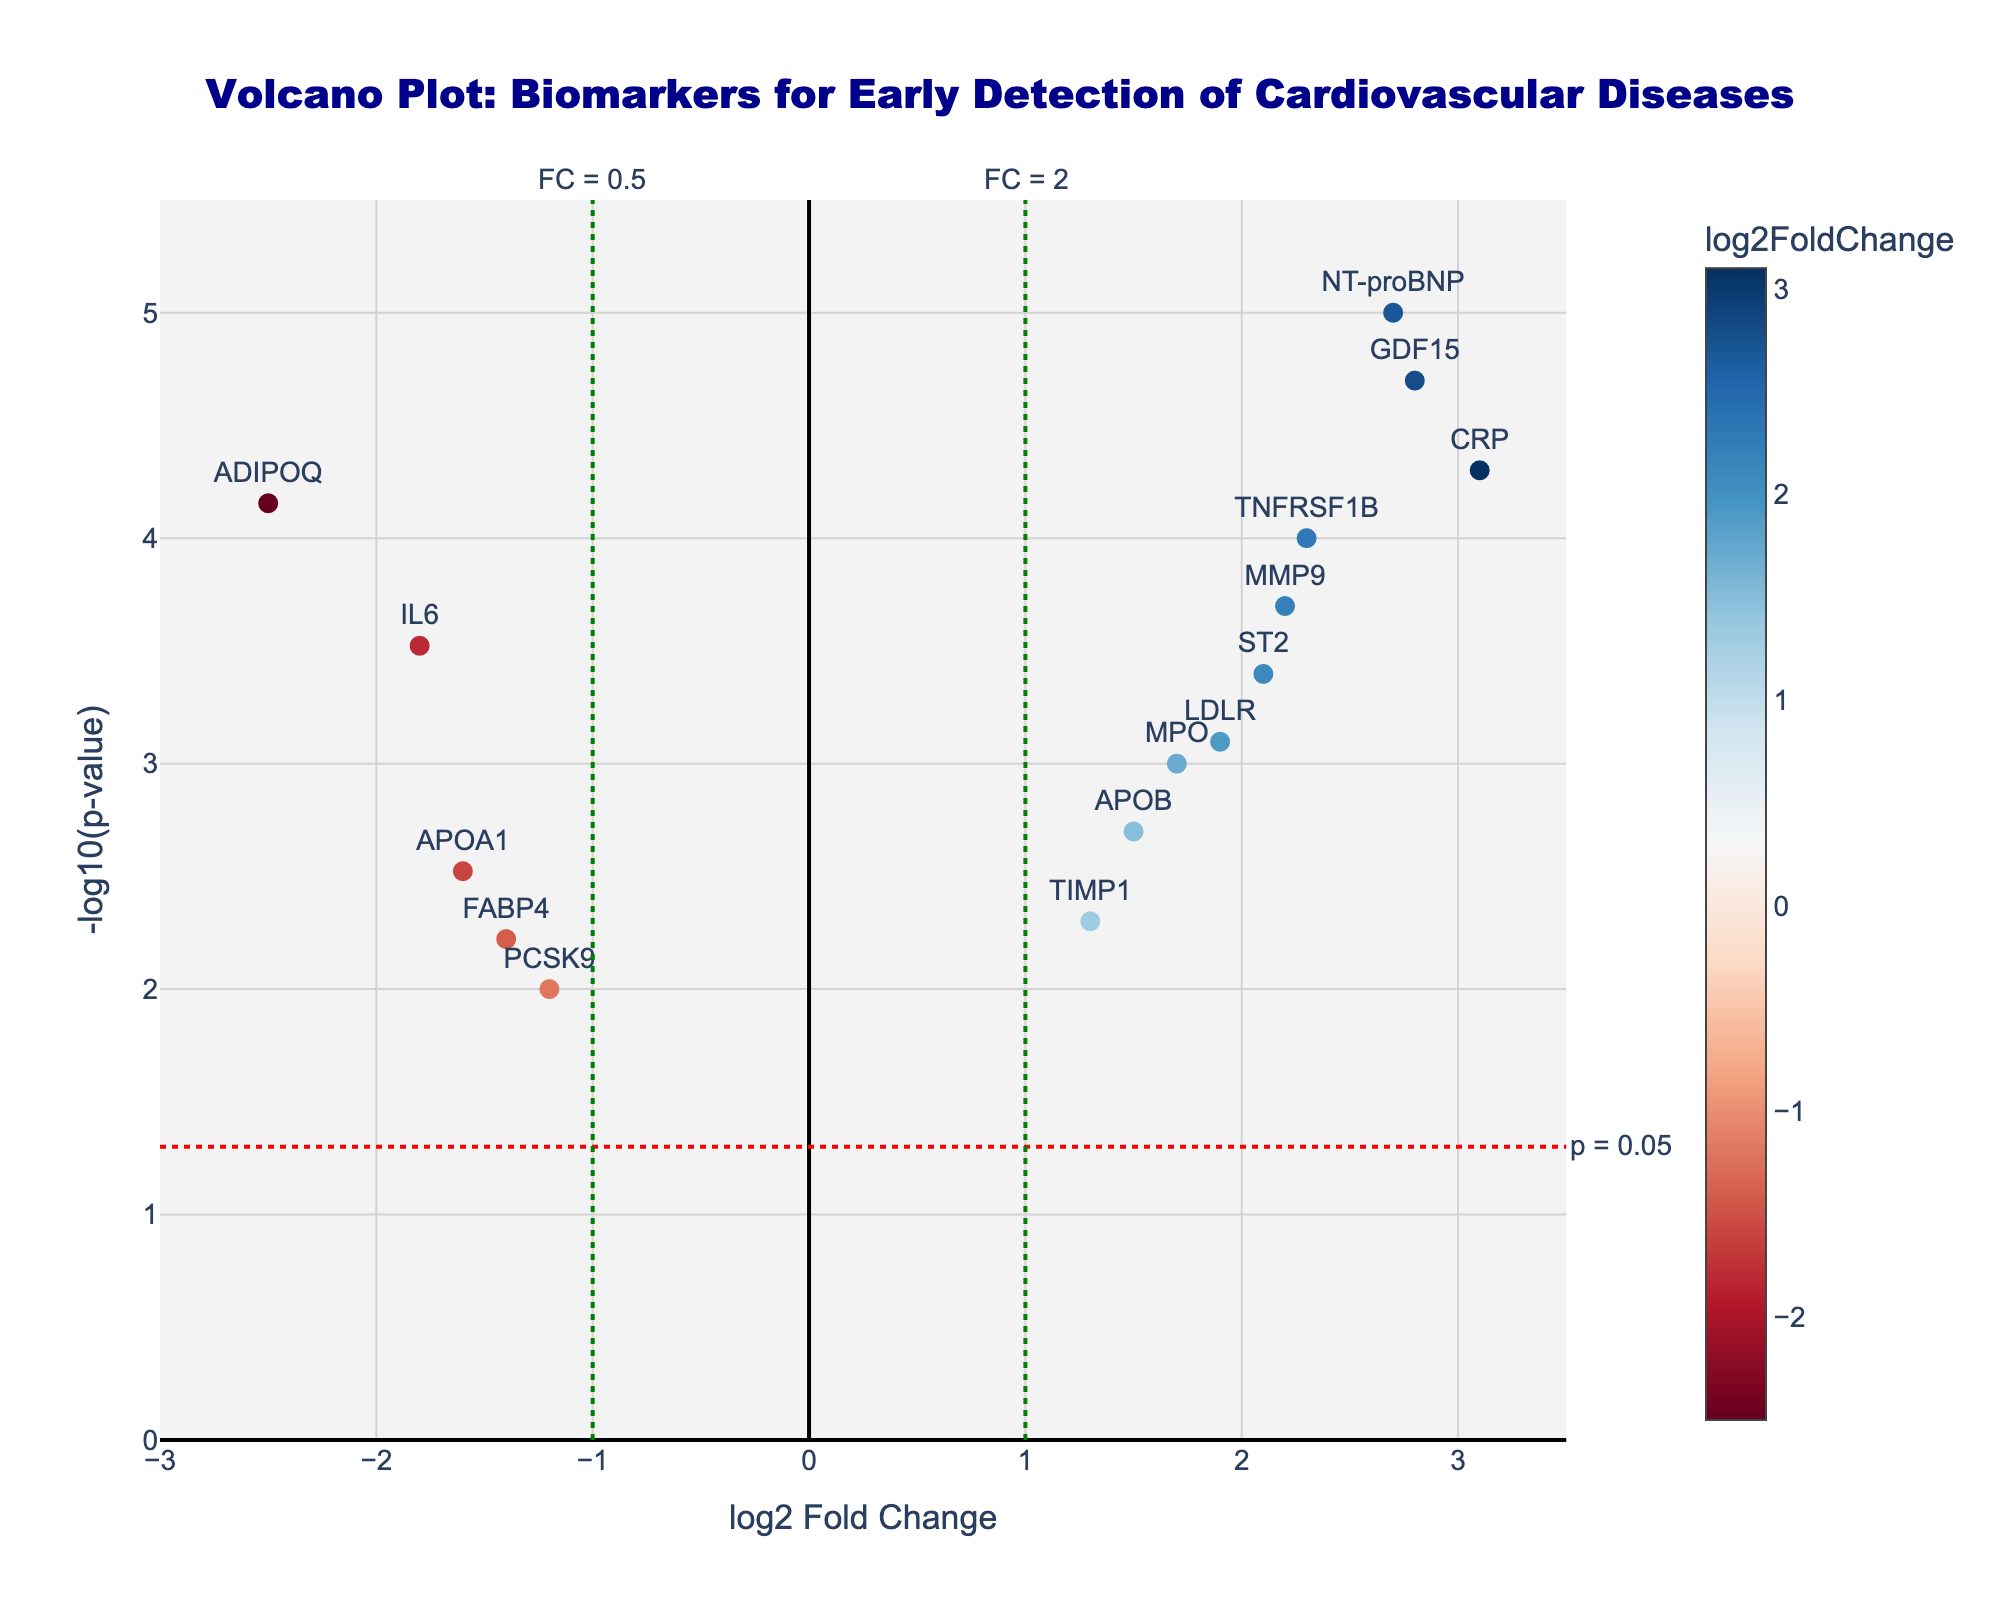What is the title of the plot? The title is usually located at the top of the plot. It provides an overview of what the plot represents.
Answer: Volcano Plot: Biomarkers for Early Detection of Cardiovascular Diseases Which axis represents the log2 Fold Change? The axis labels identify the variables being plotted. The x-axis is labeled "log2 Fold Change," which indicates that it represents the log2 Fold Change.
Answer: x-axis What is the highest -log10(p-value) in the plot and which gene corresponds to it? The highest point on the y-axis represents the highest -log10(p-value). The corresponding gene can be identified from the labels next to the points. In this case, the highest -log10(p-value) is for NT-proBNP.
Answer: NT-proBNP Which genes have a log2 Fold Change greater than 2? Look on the right side of the x-axis (greater than 2) and identify the genes above the p-value threshold (horizontal line). The genes with a log2 Fold Change greater than 2 are CRP, NT-proBNP, and GDF15.
Answer: CRP, NT-proBNP, GDF15 How many data points have a -log10(p-value) greater than 4? Points above the 4-mark on the y-axis represent -log10(p-value) greater than 4. Count these points. NT-proBNP, GDF15, and CRP are above this threshold.
Answer: 3 Which gene has the lowest log2 Fold Change? Look for the point farthest to the left along the x-axis and identify the corresponding gene. ADIPOQ has the lowest log2 Fold Change.
Answer: ADIPOQ How many genes are significantly downregulated (log2 Fold Change < -1 and p-value < 0.05)? Identify points left of the vertical line at -1 and above the horizontal p-value threshold line (red dashed line) and count these points. IL6, APOA1, and ADIPOQ meet the criteria.
Answer: 3 What is the gene with the p-value closest to 0.01? Convert the p-value into -log10(p-value) which equals 2. Look for the point closest to y=2. PCSK9 is closest to -log10(p-value) of 2.
Answer: PCSK9 Which genes are both above the p-value threshold and have log2 Fold Change values between -1 and 1? Identify points above the horizontal line (p = 0.05 threshold) and between the vertical lines at -1 and 1. TIMP1 and FABP4 fit these criteria.
Answer: TIMP1, FABP4 